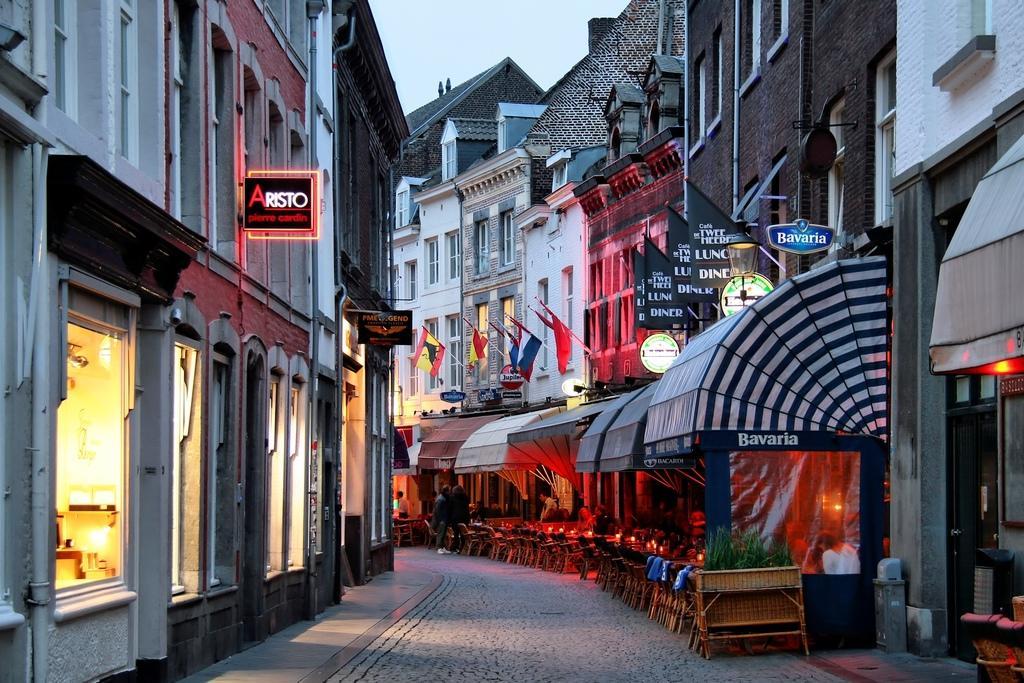How would you summarize this image in a sentence or two? On the left side there are buildings with the lights. In the middle there are dining stores, on the right side there are buildings, at the top it is the sky. 